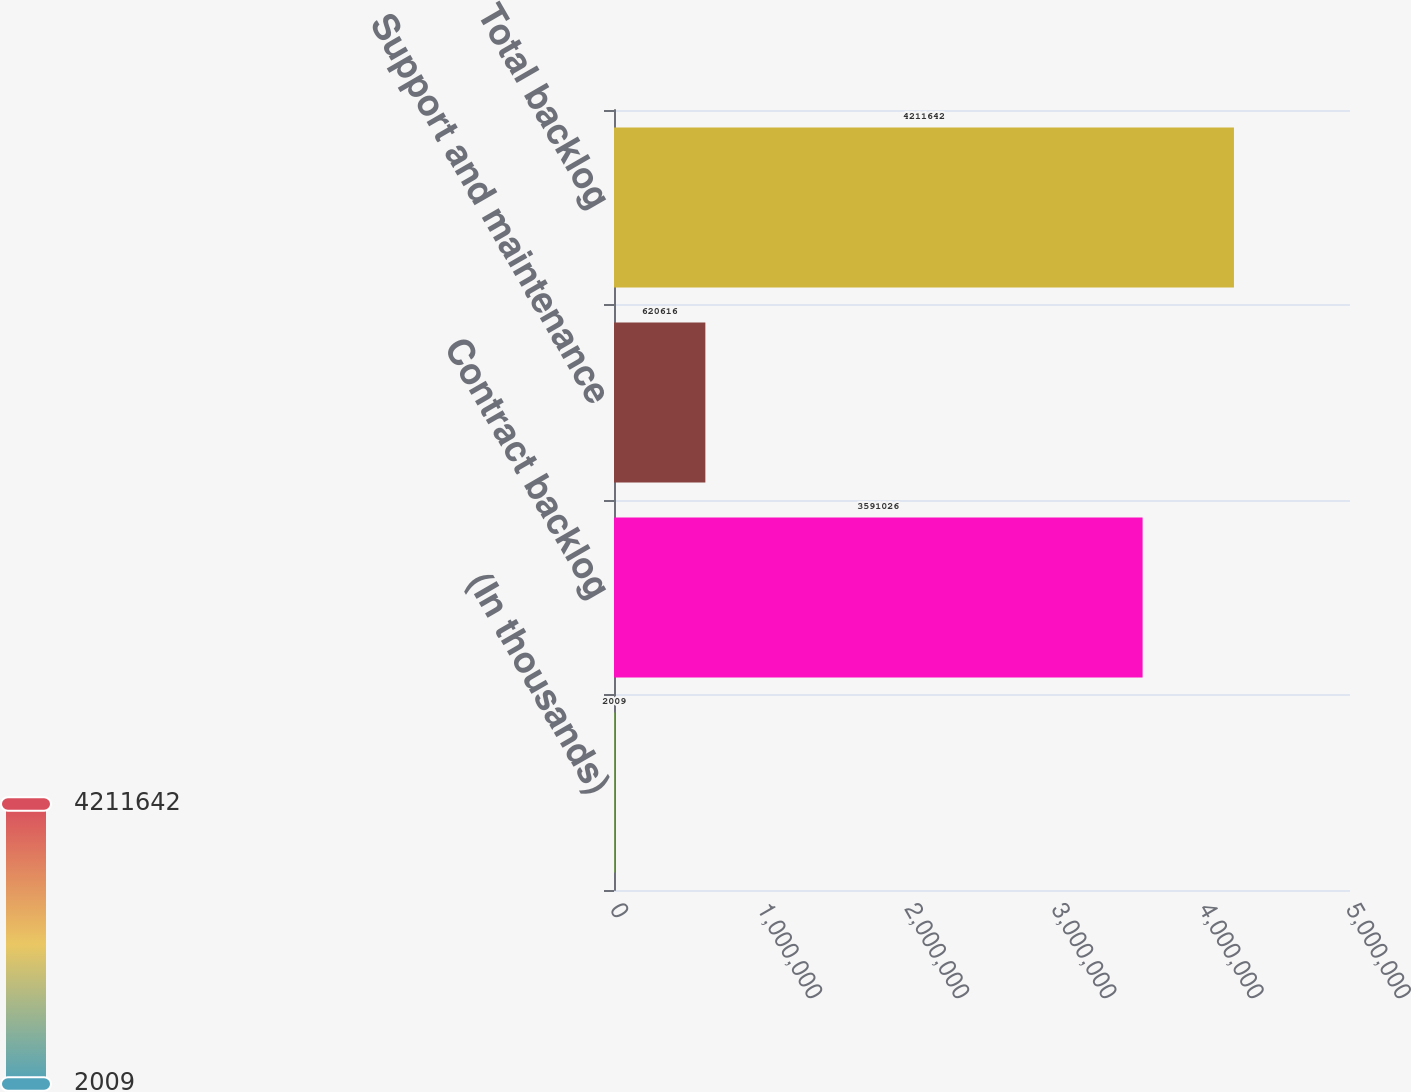<chart> <loc_0><loc_0><loc_500><loc_500><bar_chart><fcel>(In thousands)<fcel>Contract backlog<fcel>Support and maintenance<fcel>Total backlog<nl><fcel>2009<fcel>3.59103e+06<fcel>620616<fcel>4.21164e+06<nl></chart> 